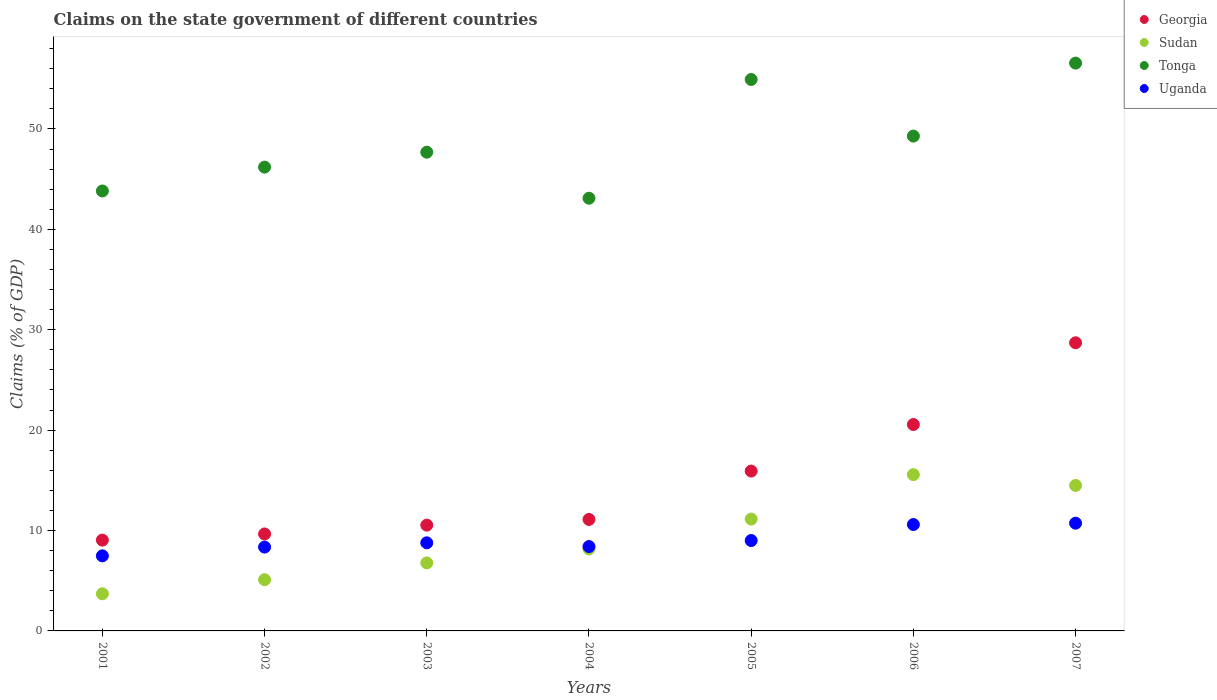Is the number of dotlines equal to the number of legend labels?
Give a very brief answer. Yes. What is the percentage of GDP claimed on the state government in Tonga in 2002?
Your answer should be very brief. 46.2. Across all years, what is the maximum percentage of GDP claimed on the state government in Uganda?
Provide a short and direct response. 10.73. Across all years, what is the minimum percentage of GDP claimed on the state government in Tonga?
Make the answer very short. 43.1. In which year was the percentage of GDP claimed on the state government in Sudan minimum?
Ensure brevity in your answer.  2001. What is the total percentage of GDP claimed on the state government in Tonga in the graph?
Keep it short and to the point. 341.59. What is the difference between the percentage of GDP claimed on the state government in Uganda in 2004 and that in 2005?
Your response must be concise. -0.6. What is the difference between the percentage of GDP claimed on the state government in Sudan in 2001 and the percentage of GDP claimed on the state government in Tonga in 2007?
Provide a short and direct response. -52.86. What is the average percentage of GDP claimed on the state government in Georgia per year?
Your answer should be compact. 15.08. In the year 2004, what is the difference between the percentage of GDP claimed on the state government in Tonga and percentage of GDP claimed on the state government in Sudan?
Make the answer very short. 34.94. In how many years, is the percentage of GDP claimed on the state government in Uganda greater than 44 %?
Provide a succinct answer. 0. What is the ratio of the percentage of GDP claimed on the state government in Tonga in 2001 to that in 2005?
Your answer should be compact. 0.8. Is the percentage of GDP claimed on the state government in Uganda in 2004 less than that in 2005?
Give a very brief answer. Yes. Is the difference between the percentage of GDP claimed on the state government in Tonga in 2001 and 2005 greater than the difference between the percentage of GDP claimed on the state government in Sudan in 2001 and 2005?
Keep it short and to the point. No. What is the difference between the highest and the second highest percentage of GDP claimed on the state government in Georgia?
Offer a very short reply. 8.14. What is the difference between the highest and the lowest percentage of GDP claimed on the state government in Tonga?
Keep it short and to the point. 13.46. In how many years, is the percentage of GDP claimed on the state government in Uganda greater than the average percentage of GDP claimed on the state government in Uganda taken over all years?
Your answer should be very brief. 2. Is it the case that in every year, the sum of the percentage of GDP claimed on the state government in Sudan and percentage of GDP claimed on the state government in Tonga  is greater than the sum of percentage of GDP claimed on the state government in Uganda and percentage of GDP claimed on the state government in Georgia?
Provide a succinct answer. Yes. Is it the case that in every year, the sum of the percentage of GDP claimed on the state government in Tonga and percentage of GDP claimed on the state government in Sudan  is greater than the percentage of GDP claimed on the state government in Uganda?
Give a very brief answer. Yes. Does the percentage of GDP claimed on the state government in Uganda monotonically increase over the years?
Your answer should be compact. No. Is the percentage of GDP claimed on the state government in Sudan strictly greater than the percentage of GDP claimed on the state government in Georgia over the years?
Provide a short and direct response. No. Is the percentage of GDP claimed on the state government in Sudan strictly less than the percentage of GDP claimed on the state government in Tonga over the years?
Your answer should be compact. Yes. How many dotlines are there?
Your answer should be very brief. 4. How many years are there in the graph?
Your answer should be very brief. 7. Does the graph contain any zero values?
Provide a short and direct response. No. How are the legend labels stacked?
Your answer should be very brief. Vertical. What is the title of the graph?
Your answer should be compact. Claims on the state government of different countries. What is the label or title of the X-axis?
Give a very brief answer. Years. What is the label or title of the Y-axis?
Make the answer very short. Claims (% of GDP). What is the Claims (% of GDP) of Georgia in 2001?
Give a very brief answer. 9.05. What is the Claims (% of GDP) of Sudan in 2001?
Your answer should be very brief. 3.7. What is the Claims (% of GDP) in Tonga in 2001?
Offer a terse response. 43.82. What is the Claims (% of GDP) in Uganda in 2001?
Your response must be concise. 7.48. What is the Claims (% of GDP) in Georgia in 2002?
Keep it short and to the point. 9.66. What is the Claims (% of GDP) of Sudan in 2002?
Make the answer very short. 5.1. What is the Claims (% of GDP) of Tonga in 2002?
Offer a very short reply. 46.2. What is the Claims (% of GDP) of Uganda in 2002?
Keep it short and to the point. 8.35. What is the Claims (% of GDP) in Georgia in 2003?
Make the answer very short. 10.54. What is the Claims (% of GDP) in Sudan in 2003?
Keep it short and to the point. 6.77. What is the Claims (% of GDP) in Tonga in 2003?
Your answer should be compact. 47.69. What is the Claims (% of GDP) of Uganda in 2003?
Your response must be concise. 8.78. What is the Claims (% of GDP) in Georgia in 2004?
Give a very brief answer. 11.1. What is the Claims (% of GDP) of Sudan in 2004?
Offer a very short reply. 8.17. What is the Claims (% of GDP) of Tonga in 2004?
Ensure brevity in your answer.  43.1. What is the Claims (% of GDP) in Uganda in 2004?
Your answer should be very brief. 8.4. What is the Claims (% of GDP) in Georgia in 2005?
Your answer should be compact. 15.92. What is the Claims (% of GDP) in Sudan in 2005?
Make the answer very short. 11.14. What is the Claims (% of GDP) of Tonga in 2005?
Offer a terse response. 54.93. What is the Claims (% of GDP) of Uganda in 2005?
Your answer should be very brief. 9. What is the Claims (% of GDP) of Georgia in 2006?
Your response must be concise. 20.56. What is the Claims (% of GDP) in Sudan in 2006?
Offer a very short reply. 15.57. What is the Claims (% of GDP) in Tonga in 2006?
Your answer should be compact. 49.29. What is the Claims (% of GDP) in Uganda in 2006?
Offer a terse response. 10.6. What is the Claims (% of GDP) in Georgia in 2007?
Provide a short and direct response. 28.7. What is the Claims (% of GDP) in Sudan in 2007?
Offer a terse response. 14.49. What is the Claims (% of GDP) of Tonga in 2007?
Your answer should be very brief. 56.56. What is the Claims (% of GDP) of Uganda in 2007?
Give a very brief answer. 10.73. Across all years, what is the maximum Claims (% of GDP) in Georgia?
Provide a succinct answer. 28.7. Across all years, what is the maximum Claims (% of GDP) in Sudan?
Provide a succinct answer. 15.57. Across all years, what is the maximum Claims (% of GDP) in Tonga?
Your response must be concise. 56.56. Across all years, what is the maximum Claims (% of GDP) of Uganda?
Your answer should be compact. 10.73. Across all years, what is the minimum Claims (% of GDP) in Georgia?
Your response must be concise. 9.05. Across all years, what is the minimum Claims (% of GDP) in Sudan?
Offer a very short reply. 3.7. Across all years, what is the minimum Claims (% of GDP) of Tonga?
Make the answer very short. 43.1. Across all years, what is the minimum Claims (% of GDP) of Uganda?
Your answer should be very brief. 7.48. What is the total Claims (% of GDP) of Georgia in the graph?
Keep it short and to the point. 105.53. What is the total Claims (% of GDP) of Sudan in the graph?
Provide a short and direct response. 64.94. What is the total Claims (% of GDP) in Tonga in the graph?
Give a very brief answer. 341.59. What is the total Claims (% of GDP) in Uganda in the graph?
Provide a short and direct response. 63.34. What is the difference between the Claims (% of GDP) of Georgia in 2001 and that in 2002?
Keep it short and to the point. -0.61. What is the difference between the Claims (% of GDP) of Sudan in 2001 and that in 2002?
Provide a short and direct response. -1.41. What is the difference between the Claims (% of GDP) in Tonga in 2001 and that in 2002?
Give a very brief answer. -2.37. What is the difference between the Claims (% of GDP) of Uganda in 2001 and that in 2002?
Offer a very short reply. -0.87. What is the difference between the Claims (% of GDP) in Georgia in 2001 and that in 2003?
Keep it short and to the point. -1.49. What is the difference between the Claims (% of GDP) in Sudan in 2001 and that in 2003?
Make the answer very short. -3.08. What is the difference between the Claims (% of GDP) of Tonga in 2001 and that in 2003?
Ensure brevity in your answer.  -3.86. What is the difference between the Claims (% of GDP) in Uganda in 2001 and that in 2003?
Give a very brief answer. -1.3. What is the difference between the Claims (% of GDP) in Georgia in 2001 and that in 2004?
Offer a very short reply. -2.06. What is the difference between the Claims (% of GDP) in Sudan in 2001 and that in 2004?
Your answer should be very brief. -4.47. What is the difference between the Claims (% of GDP) in Tonga in 2001 and that in 2004?
Keep it short and to the point. 0.72. What is the difference between the Claims (% of GDP) of Uganda in 2001 and that in 2004?
Make the answer very short. -0.92. What is the difference between the Claims (% of GDP) of Georgia in 2001 and that in 2005?
Provide a succinct answer. -6.88. What is the difference between the Claims (% of GDP) in Sudan in 2001 and that in 2005?
Provide a succinct answer. -7.44. What is the difference between the Claims (% of GDP) in Tonga in 2001 and that in 2005?
Your response must be concise. -11.1. What is the difference between the Claims (% of GDP) in Uganda in 2001 and that in 2005?
Give a very brief answer. -1.52. What is the difference between the Claims (% of GDP) of Georgia in 2001 and that in 2006?
Make the answer very short. -11.51. What is the difference between the Claims (% of GDP) of Sudan in 2001 and that in 2006?
Your response must be concise. -11.87. What is the difference between the Claims (% of GDP) in Tonga in 2001 and that in 2006?
Give a very brief answer. -5.47. What is the difference between the Claims (% of GDP) in Uganda in 2001 and that in 2006?
Your response must be concise. -3.12. What is the difference between the Claims (% of GDP) of Georgia in 2001 and that in 2007?
Your response must be concise. -19.66. What is the difference between the Claims (% of GDP) in Sudan in 2001 and that in 2007?
Your response must be concise. -10.79. What is the difference between the Claims (% of GDP) of Tonga in 2001 and that in 2007?
Keep it short and to the point. -12.74. What is the difference between the Claims (% of GDP) in Uganda in 2001 and that in 2007?
Make the answer very short. -3.25. What is the difference between the Claims (% of GDP) of Georgia in 2002 and that in 2003?
Your answer should be compact. -0.88. What is the difference between the Claims (% of GDP) in Sudan in 2002 and that in 2003?
Offer a very short reply. -1.67. What is the difference between the Claims (% of GDP) of Tonga in 2002 and that in 2003?
Give a very brief answer. -1.49. What is the difference between the Claims (% of GDP) in Uganda in 2002 and that in 2003?
Your response must be concise. -0.42. What is the difference between the Claims (% of GDP) in Georgia in 2002 and that in 2004?
Provide a short and direct response. -1.45. What is the difference between the Claims (% of GDP) of Sudan in 2002 and that in 2004?
Provide a succinct answer. -3.06. What is the difference between the Claims (% of GDP) in Tonga in 2002 and that in 2004?
Make the answer very short. 3.1. What is the difference between the Claims (% of GDP) of Uganda in 2002 and that in 2004?
Keep it short and to the point. -0.05. What is the difference between the Claims (% of GDP) in Georgia in 2002 and that in 2005?
Ensure brevity in your answer.  -6.26. What is the difference between the Claims (% of GDP) of Sudan in 2002 and that in 2005?
Your answer should be very brief. -6.04. What is the difference between the Claims (% of GDP) in Tonga in 2002 and that in 2005?
Your answer should be compact. -8.73. What is the difference between the Claims (% of GDP) of Uganda in 2002 and that in 2005?
Offer a very short reply. -0.65. What is the difference between the Claims (% of GDP) in Georgia in 2002 and that in 2006?
Ensure brevity in your answer.  -10.9. What is the difference between the Claims (% of GDP) of Sudan in 2002 and that in 2006?
Give a very brief answer. -10.46. What is the difference between the Claims (% of GDP) in Tonga in 2002 and that in 2006?
Your response must be concise. -3.09. What is the difference between the Claims (% of GDP) in Uganda in 2002 and that in 2006?
Your answer should be very brief. -2.25. What is the difference between the Claims (% of GDP) of Georgia in 2002 and that in 2007?
Offer a terse response. -19.04. What is the difference between the Claims (% of GDP) of Sudan in 2002 and that in 2007?
Offer a terse response. -9.39. What is the difference between the Claims (% of GDP) of Tonga in 2002 and that in 2007?
Your answer should be very brief. -10.36. What is the difference between the Claims (% of GDP) in Uganda in 2002 and that in 2007?
Provide a short and direct response. -2.38. What is the difference between the Claims (% of GDP) in Georgia in 2003 and that in 2004?
Provide a short and direct response. -0.57. What is the difference between the Claims (% of GDP) of Sudan in 2003 and that in 2004?
Your response must be concise. -1.39. What is the difference between the Claims (% of GDP) of Tonga in 2003 and that in 2004?
Offer a terse response. 4.58. What is the difference between the Claims (% of GDP) of Uganda in 2003 and that in 2004?
Offer a very short reply. 0.37. What is the difference between the Claims (% of GDP) of Georgia in 2003 and that in 2005?
Provide a short and direct response. -5.38. What is the difference between the Claims (% of GDP) of Sudan in 2003 and that in 2005?
Your answer should be compact. -4.36. What is the difference between the Claims (% of GDP) of Tonga in 2003 and that in 2005?
Give a very brief answer. -7.24. What is the difference between the Claims (% of GDP) of Uganda in 2003 and that in 2005?
Make the answer very short. -0.23. What is the difference between the Claims (% of GDP) in Georgia in 2003 and that in 2006?
Ensure brevity in your answer.  -10.02. What is the difference between the Claims (% of GDP) in Sudan in 2003 and that in 2006?
Provide a succinct answer. -8.79. What is the difference between the Claims (% of GDP) in Tonga in 2003 and that in 2006?
Provide a succinct answer. -1.6. What is the difference between the Claims (% of GDP) of Uganda in 2003 and that in 2006?
Provide a succinct answer. -1.82. What is the difference between the Claims (% of GDP) of Georgia in 2003 and that in 2007?
Make the answer very short. -18.16. What is the difference between the Claims (% of GDP) of Sudan in 2003 and that in 2007?
Ensure brevity in your answer.  -7.72. What is the difference between the Claims (% of GDP) of Tonga in 2003 and that in 2007?
Your answer should be compact. -8.87. What is the difference between the Claims (% of GDP) of Uganda in 2003 and that in 2007?
Ensure brevity in your answer.  -1.96. What is the difference between the Claims (% of GDP) in Georgia in 2004 and that in 2005?
Keep it short and to the point. -4.82. What is the difference between the Claims (% of GDP) of Sudan in 2004 and that in 2005?
Give a very brief answer. -2.97. What is the difference between the Claims (% of GDP) in Tonga in 2004 and that in 2005?
Ensure brevity in your answer.  -11.83. What is the difference between the Claims (% of GDP) of Uganda in 2004 and that in 2005?
Offer a very short reply. -0.6. What is the difference between the Claims (% of GDP) of Georgia in 2004 and that in 2006?
Ensure brevity in your answer.  -9.46. What is the difference between the Claims (% of GDP) of Sudan in 2004 and that in 2006?
Your answer should be compact. -7.4. What is the difference between the Claims (% of GDP) in Tonga in 2004 and that in 2006?
Provide a short and direct response. -6.19. What is the difference between the Claims (% of GDP) in Uganda in 2004 and that in 2006?
Your answer should be very brief. -2.19. What is the difference between the Claims (% of GDP) in Georgia in 2004 and that in 2007?
Your answer should be very brief. -17.6. What is the difference between the Claims (% of GDP) in Sudan in 2004 and that in 2007?
Ensure brevity in your answer.  -6.33. What is the difference between the Claims (% of GDP) of Tonga in 2004 and that in 2007?
Your answer should be compact. -13.46. What is the difference between the Claims (% of GDP) in Uganda in 2004 and that in 2007?
Keep it short and to the point. -2.33. What is the difference between the Claims (% of GDP) of Georgia in 2005 and that in 2006?
Your response must be concise. -4.64. What is the difference between the Claims (% of GDP) in Sudan in 2005 and that in 2006?
Your answer should be very brief. -4.43. What is the difference between the Claims (% of GDP) in Tonga in 2005 and that in 2006?
Make the answer very short. 5.64. What is the difference between the Claims (% of GDP) of Uganda in 2005 and that in 2006?
Provide a short and direct response. -1.6. What is the difference between the Claims (% of GDP) of Georgia in 2005 and that in 2007?
Provide a short and direct response. -12.78. What is the difference between the Claims (% of GDP) in Sudan in 2005 and that in 2007?
Provide a succinct answer. -3.35. What is the difference between the Claims (% of GDP) of Tonga in 2005 and that in 2007?
Provide a succinct answer. -1.63. What is the difference between the Claims (% of GDP) of Uganda in 2005 and that in 2007?
Provide a succinct answer. -1.73. What is the difference between the Claims (% of GDP) of Georgia in 2006 and that in 2007?
Your answer should be compact. -8.14. What is the difference between the Claims (% of GDP) in Sudan in 2006 and that in 2007?
Provide a succinct answer. 1.08. What is the difference between the Claims (% of GDP) of Tonga in 2006 and that in 2007?
Provide a short and direct response. -7.27. What is the difference between the Claims (% of GDP) of Uganda in 2006 and that in 2007?
Ensure brevity in your answer.  -0.13. What is the difference between the Claims (% of GDP) of Georgia in 2001 and the Claims (% of GDP) of Sudan in 2002?
Your response must be concise. 3.94. What is the difference between the Claims (% of GDP) in Georgia in 2001 and the Claims (% of GDP) in Tonga in 2002?
Give a very brief answer. -37.15. What is the difference between the Claims (% of GDP) in Georgia in 2001 and the Claims (% of GDP) in Uganda in 2002?
Offer a very short reply. 0.69. What is the difference between the Claims (% of GDP) in Sudan in 2001 and the Claims (% of GDP) in Tonga in 2002?
Provide a succinct answer. -42.5. What is the difference between the Claims (% of GDP) of Sudan in 2001 and the Claims (% of GDP) of Uganda in 2002?
Give a very brief answer. -4.65. What is the difference between the Claims (% of GDP) in Tonga in 2001 and the Claims (% of GDP) in Uganda in 2002?
Ensure brevity in your answer.  35.47. What is the difference between the Claims (% of GDP) in Georgia in 2001 and the Claims (% of GDP) in Sudan in 2003?
Keep it short and to the point. 2.27. What is the difference between the Claims (% of GDP) in Georgia in 2001 and the Claims (% of GDP) in Tonga in 2003?
Give a very brief answer. -38.64. What is the difference between the Claims (% of GDP) in Georgia in 2001 and the Claims (% of GDP) in Uganda in 2003?
Offer a terse response. 0.27. What is the difference between the Claims (% of GDP) in Sudan in 2001 and the Claims (% of GDP) in Tonga in 2003?
Your answer should be very brief. -43.99. What is the difference between the Claims (% of GDP) in Sudan in 2001 and the Claims (% of GDP) in Uganda in 2003?
Offer a very short reply. -5.08. What is the difference between the Claims (% of GDP) of Tonga in 2001 and the Claims (% of GDP) of Uganda in 2003?
Your answer should be compact. 35.05. What is the difference between the Claims (% of GDP) of Georgia in 2001 and the Claims (% of GDP) of Sudan in 2004?
Keep it short and to the point. 0.88. What is the difference between the Claims (% of GDP) of Georgia in 2001 and the Claims (% of GDP) of Tonga in 2004?
Make the answer very short. -34.06. What is the difference between the Claims (% of GDP) of Georgia in 2001 and the Claims (% of GDP) of Uganda in 2004?
Offer a terse response. 0.64. What is the difference between the Claims (% of GDP) in Sudan in 2001 and the Claims (% of GDP) in Tonga in 2004?
Keep it short and to the point. -39.4. What is the difference between the Claims (% of GDP) of Sudan in 2001 and the Claims (% of GDP) of Uganda in 2004?
Offer a terse response. -4.71. What is the difference between the Claims (% of GDP) in Tonga in 2001 and the Claims (% of GDP) in Uganda in 2004?
Keep it short and to the point. 35.42. What is the difference between the Claims (% of GDP) of Georgia in 2001 and the Claims (% of GDP) of Sudan in 2005?
Offer a terse response. -2.09. What is the difference between the Claims (% of GDP) in Georgia in 2001 and the Claims (% of GDP) in Tonga in 2005?
Give a very brief answer. -45.88. What is the difference between the Claims (% of GDP) of Georgia in 2001 and the Claims (% of GDP) of Uganda in 2005?
Give a very brief answer. 0.04. What is the difference between the Claims (% of GDP) of Sudan in 2001 and the Claims (% of GDP) of Tonga in 2005?
Give a very brief answer. -51.23. What is the difference between the Claims (% of GDP) in Sudan in 2001 and the Claims (% of GDP) in Uganda in 2005?
Provide a short and direct response. -5.3. What is the difference between the Claims (% of GDP) of Tonga in 2001 and the Claims (% of GDP) of Uganda in 2005?
Provide a succinct answer. 34.82. What is the difference between the Claims (% of GDP) in Georgia in 2001 and the Claims (% of GDP) in Sudan in 2006?
Offer a very short reply. -6.52. What is the difference between the Claims (% of GDP) in Georgia in 2001 and the Claims (% of GDP) in Tonga in 2006?
Your answer should be compact. -40.24. What is the difference between the Claims (% of GDP) of Georgia in 2001 and the Claims (% of GDP) of Uganda in 2006?
Your answer should be compact. -1.55. What is the difference between the Claims (% of GDP) in Sudan in 2001 and the Claims (% of GDP) in Tonga in 2006?
Your response must be concise. -45.59. What is the difference between the Claims (% of GDP) in Sudan in 2001 and the Claims (% of GDP) in Uganda in 2006?
Give a very brief answer. -6.9. What is the difference between the Claims (% of GDP) of Tonga in 2001 and the Claims (% of GDP) of Uganda in 2006?
Your answer should be very brief. 33.23. What is the difference between the Claims (% of GDP) in Georgia in 2001 and the Claims (% of GDP) in Sudan in 2007?
Ensure brevity in your answer.  -5.45. What is the difference between the Claims (% of GDP) of Georgia in 2001 and the Claims (% of GDP) of Tonga in 2007?
Make the answer very short. -47.51. What is the difference between the Claims (% of GDP) of Georgia in 2001 and the Claims (% of GDP) of Uganda in 2007?
Provide a short and direct response. -1.69. What is the difference between the Claims (% of GDP) of Sudan in 2001 and the Claims (% of GDP) of Tonga in 2007?
Provide a short and direct response. -52.86. What is the difference between the Claims (% of GDP) in Sudan in 2001 and the Claims (% of GDP) in Uganda in 2007?
Keep it short and to the point. -7.03. What is the difference between the Claims (% of GDP) in Tonga in 2001 and the Claims (% of GDP) in Uganda in 2007?
Give a very brief answer. 33.09. What is the difference between the Claims (% of GDP) of Georgia in 2002 and the Claims (% of GDP) of Sudan in 2003?
Provide a short and direct response. 2.88. What is the difference between the Claims (% of GDP) in Georgia in 2002 and the Claims (% of GDP) in Tonga in 2003?
Offer a very short reply. -38.03. What is the difference between the Claims (% of GDP) of Georgia in 2002 and the Claims (% of GDP) of Uganda in 2003?
Provide a short and direct response. 0.88. What is the difference between the Claims (% of GDP) in Sudan in 2002 and the Claims (% of GDP) in Tonga in 2003?
Offer a very short reply. -42.58. What is the difference between the Claims (% of GDP) in Sudan in 2002 and the Claims (% of GDP) in Uganda in 2003?
Keep it short and to the point. -3.67. What is the difference between the Claims (% of GDP) of Tonga in 2002 and the Claims (% of GDP) of Uganda in 2003?
Make the answer very short. 37.42. What is the difference between the Claims (% of GDP) in Georgia in 2002 and the Claims (% of GDP) in Sudan in 2004?
Your answer should be compact. 1.49. What is the difference between the Claims (% of GDP) of Georgia in 2002 and the Claims (% of GDP) of Tonga in 2004?
Offer a terse response. -33.44. What is the difference between the Claims (% of GDP) in Georgia in 2002 and the Claims (% of GDP) in Uganda in 2004?
Give a very brief answer. 1.25. What is the difference between the Claims (% of GDP) in Sudan in 2002 and the Claims (% of GDP) in Tonga in 2004?
Your answer should be very brief. -38. What is the difference between the Claims (% of GDP) of Sudan in 2002 and the Claims (% of GDP) of Uganda in 2004?
Keep it short and to the point. -3.3. What is the difference between the Claims (% of GDP) in Tonga in 2002 and the Claims (% of GDP) in Uganda in 2004?
Your answer should be compact. 37.79. What is the difference between the Claims (% of GDP) in Georgia in 2002 and the Claims (% of GDP) in Sudan in 2005?
Ensure brevity in your answer.  -1.48. What is the difference between the Claims (% of GDP) in Georgia in 2002 and the Claims (% of GDP) in Tonga in 2005?
Your answer should be very brief. -45.27. What is the difference between the Claims (% of GDP) in Georgia in 2002 and the Claims (% of GDP) in Uganda in 2005?
Ensure brevity in your answer.  0.66. What is the difference between the Claims (% of GDP) of Sudan in 2002 and the Claims (% of GDP) of Tonga in 2005?
Make the answer very short. -49.82. What is the difference between the Claims (% of GDP) of Sudan in 2002 and the Claims (% of GDP) of Uganda in 2005?
Offer a terse response. -3.9. What is the difference between the Claims (% of GDP) in Tonga in 2002 and the Claims (% of GDP) in Uganda in 2005?
Your answer should be very brief. 37.2. What is the difference between the Claims (% of GDP) of Georgia in 2002 and the Claims (% of GDP) of Sudan in 2006?
Your response must be concise. -5.91. What is the difference between the Claims (% of GDP) in Georgia in 2002 and the Claims (% of GDP) in Tonga in 2006?
Ensure brevity in your answer.  -39.63. What is the difference between the Claims (% of GDP) of Georgia in 2002 and the Claims (% of GDP) of Uganda in 2006?
Offer a very short reply. -0.94. What is the difference between the Claims (% of GDP) in Sudan in 2002 and the Claims (% of GDP) in Tonga in 2006?
Make the answer very short. -44.19. What is the difference between the Claims (% of GDP) of Sudan in 2002 and the Claims (% of GDP) of Uganda in 2006?
Give a very brief answer. -5.49. What is the difference between the Claims (% of GDP) of Tonga in 2002 and the Claims (% of GDP) of Uganda in 2006?
Provide a succinct answer. 35.6. What is the difference between the Claims (% of GDP) of Georgia in 2002 and the Claims (% of GDP) of Sudan in 2007?
Provide a succinct answer. -4.83. What is the difference between the Claims (% of GDP) in Georgia in 2002 and the Claims (% of GDP) in Tonga in 2007?
Ensure brevity in your answer.  -46.9. What is the difference between the Claims (% of GDP) of Georgia in 2002 and the Claims (% of GDP) of Uganda in 2007?
Your answer should be compact. -1.07. What is the difference between the Claims (% of GDP) of Sudan in 2002 and the Claims (% of GDP) of Tonga in 2007?
Make the answer very short. -51.46. What is the difference between the Claims (% of GDP) of Sudan in 2002 and the Claims (% of GDP) of Uganda in 2007?
Offer a terse response. -5.63. What is the difference between the Claims (% of GDP) of Tonga in 2002 and the Claims (% of GDP) of Uganda in 2007?
Keep it short and to the point. 35.47. What is the difference between the Claims (% of GDP) in Georgia in 2003 and the Claims (% of GDP) in Sudan in 2004?
Your answer should be compact. 2.37. What is the difference between the Claims (% of GDP) in Georgia in 2003 and the Claims (% of GDP) in Tonga in 2004?
Offer a very short reply. -32.56. What is the difference between the Claims (% of GDP) of Georgia in 2003 and the Claims (% of GDP) of Uganda in 2004?
Give a very brief answer. 2.13. What is the difference between the Claims (% of GDP) of Sudan in 2003 and the Claims (% of GDP) of Tonga in 2004?
Keep it short and to the point. -36.33. What is the difference between the Claims (% of GDP) in Sudan in 2003 and the Claims (% of GDP) in Uganda in 2004?
Provide a short and direct response. -1.63. What is the difference between the Claims (% of GDP) of Tonga in 2003 and the Claims (% of GDP) of Uganda in 2004?
Your response must be concise. 39.28. What is the difference between the Claims (% of GDP) in Georgia in 2003 and the Claims (% of GDP) in Sudan in 2005?
Your response must be concise. -0.6. What is the difference between the Claims (% of GDP) of Georgia in 2003 and the Claims (% of GDP) of Tonga in 2005?
Provide a succinct answer. -44.39. What is the difference between the Claims (% of GDP) in Georgia in 2003 and the Claims (% of GDP) in Uganda in 2005?
Give a very brief answer. 1.53. What is the difference between the Claims (% of GDP) in Sudan in 2003 and the Claims (% of GDP) in Tonga in 2005?
Keep it short and to the point. -48.15. What is the difference between the Claims (% of GDP) in Sudan in 2003 and the Claims (% of GDP) in Uganda in 2005?
Your answer should be very brief. -2.23. What is the difference between the Claims (% of GDP) of Tonga in 2003 and the Claims (% of GDP) of Uganda in 2005?
Your answer should be very brief. 38.68. What is the difference between the Claims (% of GDP) of Georgia in 2003 and the Claims (% of GDP) of Sudan in 2006?
Provide a short and direct response. -5.03. What is the difference between the Claims (% of GDP) of Georgia in 2003 and the Claims (% of GDP) of Tonga in 2006?
Ensure brevity in your answer.  -38.75. What is the difference between the Claims (% of GDP) in Georgia in 2003 and the Claims (% of GDP) in Uganda in 2006?
Ensure brevity in your answer.  -0.06. What is the difference between the Claims (% of GDP) of Sudan in 2003 and the Claims (% of GDP) of Tonga in 2006?
Give a very brief answer. -42.51. What is the difference between the Claims (% of GDP) in Sudan in 2003 and the Claims (% of GDP) in Uganda in 2006?
Offer a terse response. -3.82. What is the difference between the Claims (% of GDP) of Tonga in 2003 and the Claims (% of GDP) of Uganda in 2006?
Your response must be concise. 37.09. What is the difference between the Claims (% of GDP) of Georgia in 2003 and the Claims (% of GDP) of Sudan in 2007?
Ensure brevity in your answer.  -3.95. What is the difference between the Claims (% of GDP) in Georgia in 2003 and the Claims (% of GDP) in Tonga in 2007?
Offer a terse response. -46.02. What is the difference between the Claims (% of GDP) in Georgia in 2003 and the Claims (% of GDP) in Uganda in 2007?
Give a very brief answer. -0.19. What is the difference between the Claims (% of GDP) in Sudan in 2003 and the Claims (% of GDP) in Tonga in 2007?
Provide a succinct answer. -49.78. What is the difference between the Claims (% of GDP) in Sudan in 2003 and the Claims (% of GDP) in Uganda in 2007?
Provide a short and direct response. -3.96. What is the difference between the Claims (% of GDP) in Tonga in 2003 and the Claims (% of GDP) in Uganda in 2007?
Keep it short and to the point. 36.96. What is the difference between the Claims (% of GDP) of Georgia in 2004 and the Claims (% of GDP) of Sudan in 2005?
Keep it short and to the point. -0.04. What is the difference between the Claims (% of GDP) in Georgia in 2004 and the Claims (% of GDP) in Tonga in 2005?
Provide a succinct answer. -43.82. What is the difference between the Claims (% of GDP) of Georgia in 2004 and the Claims (% of GDP) of Uganda in 2005?
Provide a short and direct response. 2.1. What is the difference between the Claims (% of GDP) in Sudan in 2004 and the Claims (% of GDP) in Tonga in 2005?
Your answer should be very brief. -46.76. What is the difference between the Claims (% of GDP) of Sudan in 2004 and the Claims (% of GDP) of Uganda in 2005?
Offer a terse response. -0.84. What is the difference between the Claims (% of GDP) of Tonga in 2004 and the Claims (% of GDP) of Uganda in 2005?
Offer a terse response. 34.1. What is the difference between the Claims (% of GDP) of Georgia in 2004 and the Claims (% of GDP) of Sudan in 2006?
Your answer should be very brief. -4.46. What is the difference between the Claims (% of GDP) of Georgia in 2004 and the Claims (% of GDP) of Tonga in 2006?
Your response must be concise. -38.19. What is the difference between the Claims (% of GDP) of Georgia in 2004 and the Claims (% of GDP) of Uganda in 2006?
Make the answer very short. 0.51. What is the difference between the Claims (% of GDP) of Sudan in 2004 and the Claims (% of GDP) of Tonga in 2006?
Ensure brevity in your answer.  -41.12. What is the difference between the Claims (% of GDP) of Sudan in 2004 and the Claims (% of GDP) of Uganda in 2006?
Ensure brevity in your answer.  -2.43. What is the difference between the Claims (% of GDP) of Tonga in 2004 and the Claims (% of GDP) of Uganda in 2006?
Give a very brief answer. 32.5. What is the difference between the Claims (% of GDP) of Georgia in 2004 and the Claims (% of GDP) of Sudan in 2007?
Your answer should be compact. -3.39. What is the difference between the Claims (% of GDP) in Georgia in 2004 and the Claims (% of GDP) in Tonga in 2007?
Your response must be concise. -45.45. What is the difference between the Claims (% of GDP) in Georgia in 2004 and the Claims (% of GDP) in Uganda in 2007?
Your response must be concise. 0.37. What is the difference between the Claims (% of GDP) of Sudan in 2004 and the Claims (% of GDP) of Tonga in 2007?
Keep it short and to the point. -48.39. What is the difference between the Claims (% of GDP) in Sudan in 2004 and the Claims (% of GDP) in Uganda in 2007?
Your answer should be compact. -2.57. What is the difference between the Claims (% of GDP) of Tonga in 2004 and the Claims (% of GDP) of Uganda in 2007?
Provide a succinct answer. 32.37. What is the difference between the Claims (% of GDP) in Georgia in 2005 and the Claims (% of GDP) in Sudan in 2006?
Your answer should be compact. 0.35. What is the difference between the Claims (% of GDP) in Georgia in 2005 and the Claims (% of GDP) in Tonga in 2006?
Offer a very short reply. -33.37. What is the difference between the Claims (% of GDP) in Georgia in 2005 and the Claims (% of GDP) in Uganda in 2006?
Ensure brevity in your answer.  5.32. What is the difference between the Claims (% of GDP) of Sudan in 2005 and the Claims (% of GDP) of Tonga in 2006?
Make the answer very short. -38.15. What is the difference between the Claims (% of GDP) in Sudan in 2005 and the Claims (% of GDP) in Uganda in 2006?
Provide a short and direct response. 0.54. What is the difference between the Claims (% of GDP) of Tonga in 2005 and the Claims (% of GDP) of Uganda in 2006?
Offer a very short reply. 44.33. What is the difference between the Claims (% of GDP) of Georgia in 2005 and the Claims (% of GDP) of Sudan in 2007?
Make the answer very short. 1.43. What is the difference between the Claims (% of GDP) in Georgia in 2005 and the Claims (% of GDP) in Tonga in 2007?
Keep it short and to the point. -40.64. What is the difference between the Claims (% of GDP) in Georgia in 2005 and the Claims (% of GDP) in Uganda in 2007?
Provide a short and direct response. 5.19. What is the difference between the Claims (% of GDP) in Sudan in 2005 and the Claims (% of GDP) in Tonga in 2007?
Offer a terse response. -45.42. What is the difference between the Claims (% of GDP) in Sudan in 2005 and the Claims (% of GDP) in Uganda in 2007?
Provide a succinct answer. 0.41. What is the difference between the Claims (% of GDP) in Tonga in 2005 and the Claims (% of GDP) in Uganda in 2007?
Give a very brief answer. 44.2. What is the difference between the Claims (% of GDP) in Georgia in 2006 and the Claims (% of GDP) in Sudan in 2007?
Your response must be concise. 6.07. What is the difference between the Claims (% of GDP) of Georgia in 2006 and the Claims (% of GDP) of Tonga in 2007?
Keep it short and to the point. -36. What is the difference between the Claims (% of GDP) in Georgia in 2006 and the Claims (% of GDP) in Uganda in 2007?
Your answer should be very brief. 9.83. What is the difference between the Claims (% of GDP) of Sudan in 2006 and the Claims (% of GDP) of Tonga in 2007?
Your answer should be compact. -40.99. What is the difference between the Claims (% of GDP) of Sudan in 2006 and the Claims (% of GDP) of Uganda in 2007?
Make the answer very short. 4.84. What is the difference between the Claims (% of GDP) in Tonga in 2006 and the Claims (% of GDP) in Uganda in 2007?
Ensure brevity in your answer.  38.56. What is the average Claims (% of GDP) of Georgia per year?
Offer a very short reply. 15.08. What is the average Claims (% of GDP) in Sudan per year?
Ensure brevity in your answer.  9.28. What is the average Claims (% of GDP) in Tonga per year?
Make the answer very short. 48.8. What is the average Claims (% of GDP) in Uganda per year?
Your response must be concise. 9.05. In the year 2001, what is the difference between the Claims (% of GDP) in Georgia and Claims (% of GDP) in Sudan?
Offer a terse response. 5.35. In the year 2001, what is the difference between the Claims (% of GDP) in Georgia and Claims (% of GDP) in Tonga?
Keep it short and to the point. -34.78. In the year 2001, what is the difference between the Claims (% of GDP) in Georgia and Claims (% of GDP) in Uganda?
Provide a short and direct response. 1.57. In the year 2001, what is the difference between the Claims (% of GDP) of Sudan and Claims (% of GDP) of Tonga?
Your answer should be compact. -40.12. In the year 2001, what is the difference between the Claims (% of GDP) in Sudan and Claims (% of GDP) in Uganda?
Provide a succinct answer. -3.78. In the year 2001, what is the difference between the Claims (% of GDP) of Tonga and Claims (% of GDP) of Uganda?
Offer a terse response. 36.34. In the year 2002, what is the difference between the Claims (% of GDP) in Georgia and Claims (% of GDP) in Sudan?
Offer a very short reply. 4.55. In the year 2002, what is the difference between the Claims (% of GDP) in Georgia and Claims (% of GDP) in Tonga?
Your response must be concise. -36.54. In the year 2002, what is the difference between the Claims (% of GDP) of Georgia and Claims (% of GDP) of Uganda?
Ensure brevity in your answer.  1.31. In the year 2002, what is the difference between the Claims (% of GDP) of Sudan and Claims (% of GDP) of Tonga?
Give a very brief answer. -41.09. In the year 2002, what is the difference between the Claims (% of GDP) of Sudan and Claims (% of GDP) of Uganda?
Make the answer very short. -3.25. In the year 2002, what is the difference between the Claims (% of GDP) in Tonga and Claims (% of GDP) in Uganda?
Your response must be concise. 37.85. In the year 2003, what is the difference between the Claims (% of GDP) in Georgia and Claims (% of GDP) in Sudan?
Keep it short and to the point. 3.76. In the year 2003, what is the difference between the Claims (% of GDP) of Georgia and Claims (% of GDP) of Tonga?
Keep it short and to the point. -37.15. In the year 2003, what is the difference between the Claims (% of GDP) of Georgia and Claims (% of GDP) of Uganda?
Your answer should be very brief. 1.76. In the year 2003, what is the difference between the Claims (% of GDP) of Sudan and Claims (% of GDP) of Tonga?
Provide a short and direct response. -40.91. In the year 2003, what is the difference between the Claims (% of GDP) of Sudan and Claims (% of GDP) of Uganda?
Keep it short and to the point. -2. In the year 2003, what is the difference between the Claims (% of GDP) in Tonga and Claims (% of GDP) in Uganda?
Make the answer very short. 38.91. In the year 2004, what is the difference between the Claims (% of GDP) in Georgia and Claims (% of GDP) in Sudan?
Offer a terse response. 2.94. In the year 2004, what is the difference between the Claims (% of GDP) of Georgia and Claims (% of GDP) of Tonga?
Give a very brief answer. -32. In the year 2004, what is the difference between the Claims (% of GDP) of Georgia and Claims (% of GDP) of Uganda?
Ensure brevity in your answer.  2.7. In the year 2004, what is the difference between the Claims (% of GDP) of Sudan and Claims (% of GDP) of Tonga?
Ensure brevity in your answer.  -34.94. In the year 2004, what is the difference between the Claims (% of GDP) of Sudan and Claims (% of GDP) of Uganda?
Offer a terse response. -0.24. In the year 2004, what is the difference between the Claims (% of GDP) in Tonga and Claims (% of GDP) in Uganda?
Provide a short and direct response. 34.7. In the year 2005, what is the difference between the Claims (% of GDP) in Georgia and Claims (% of GDP) in Sudan?
Your answer should be very brief. 4.78. In the year 2005, what is the difference between the Claims (% of GDP) of Georgia and Claims (% of GDP) of Tonga?
Provide a succinct answer. -39.01. In the year 2005, what is the difference between the Claims (% of GDP) of Georgia and Claims (% of GDP) of Uganda?
Your answer should be compact. 6.92. In the year 2005, what is the difference between the Claims (% of GDP) in Sudan and Claims (% of GDP) in Tonga?
Give a very brief answer. -43.79. In the year 2005, what is the difference between the Claims (% of GDP) in Sudan and Claims (% of GDP) in Uganda?
Your response must be concise. 2.14. In the year 2005, what is the difference between the Claims (% of GDP) of Tonga and Claims (% of GDP) of Uganda?
Ensure brevity in your answer.  45.93. In the year 2006, what is the difference between the Claims (% of GDP) of Georgia and Claims (% of GDP) of Sudan?
Keep it short and to the point. 4.99. In the year 2006, what is the difference between the Claims (% of GDP) in Georgia and Claims (% of GDP) in Tonga?
Your response must be concise. -28.73. In the year 2006, what is the difference between the Claims (% of GDP) of Georgia and Claims (% of GDP) of Uganda?
Offer a very short reply. 9.96. In the year 2006, what is the difference between the Claims (% of GDP) of Sudan and Claims (% of GDP) of Tonga?
Your response must be concise. -33.72. In the year 2006, what is the difference between the Claims (% of GDP) in Sudan and Claims (% of GDP) in Uganda?
Your response must be concise. 4.97. In the year 2006, what is the difference between the Claims (% of GDP) in Tonga and Claims (% of GDP) in Uganda?
Offer a very short reply. 38.69. In the year 2007, what is the difference between the Claims (% of GDP) of Georgia and Claims (% of GDP) of Sudan?
Make the answer very short. 14.21. In the year 2007, what is the difference between the Claims (% of GDP) of Georgia and Claims (% of GDP) of Tonga?
Your answer should be compact. -27.86. In the year 2007, what is the difference between the Claims (% of GDP) of Georgia and Claims (% of GDP) of Uganda?
Provide a succinct answer. 17.97. In the year 2007, what is the difference between the Claims (% of GDP) in Sudan and Claims (% of GDP) in Tonga?
Provide a short and direct response. -42.07. In the year 2007, what is the difference between the Claims (% of GDP) of Sudan and Claims (% of GDP) of Uganda?
Ensure brevity in your answer.  3.76. In the year 2007, what is the difference between the Claims (% of GDP) of Tonga and Claims (% of GDP) of Uganda?
Your answer should be very brief. 45.83. What is the ratio of the Claims (% of GDP) in Georgia in 2001 to that in 2002?
Your answer should be very brief. 0.94. What is the ratio of the Claims (% of GDP) of Sudan in 2001 to that in 2002?
Offer a very short reply. 0.72. What is the ratio of the Claims (% of GDP) in Tonga in 2001 to that in 2002?
Offer a very short reply. 0.95. What is the ratio of the Claims (% of GDP) of Uganda in 2001 to that in 2002?
Your answer should be compact. 0.9. What is the ratio of the Claims (% of GDP) in Georgia in 2001 to that in 2003?
Your answer should be very brief. 0.86. What is the ratio of the Claims (% of GDP) of Sudan in 2001 to that in 2003?
Your answer should be compact. 0.55. What is the ratio of the Claims (% of GDP) of Tonga in 2001 to that in 2003?
Keep it short and to the point. 0.92. What is the ratio of the Claims (% of GDP) in Uganda in 2001 to that in 2003?
Offer a very short reply. 0.85. What is the ratio of the Claims (% of GDP) in Georgia in 2001 to that in 2004?
Make the answer very short. 0.81. What is the ratio of the Claims (% of GDP) of Sudan in 2001 to that in 2004?
Give a very brief answer. 0.45. What is the ratio of the Claims (% of GDP) of Tonga in 2001 to that in 2004?
Offer a terse response. 1.02. What is the ratio of the Claims (% of GDP) in Uganda in 2001 to that in 2004?
Give a very brief answer. 0.89. What is the ratio of the Claims (% of GDP) in Georgia in 2001 to that in 2005?
Your answer should be very brief. 0.57. What is the ratio of the Claims (% of GDP) in Sudan in 2001 to that in 2005?
Your answer should be compact. 0.33. What is the ratio of the Claims (% of GDP) of Tonga in 2001 to that in 2005?
Provide a succinct answer. 0.8. What is the ratio of the Claims (% of GDP) of Uganda in 2001 to that in 2005?
Keep it short and to the point. 0.83. What is the ratio of the Claims (% of GDP) of Georgia in 2001 to that in 2006?
Your answer should be very brief. 0.44. What is the ratio of the Claims (% of GDP) in Sudan in 2001 to that in 2006?
Your answer should be very brief. 0.24. What is the ratio of the Claims (% of GDP) in Tonga in 2001 to that in 2006?
Offer a terse response. 0.89. What is the ratio of the Claims (% of GDP) in Uganda in 2001 to that in 2006?
Provide a short and direct response. 0.71. What is the ratio of the Claims (% of GDP) in Georgia in 2001 to that in 2007?
Your answer should be very brief. 0.32. What is the ratio of the Claims (% of GDP) of Sudan in 2001 to that in 2007?
Keep it short and to the point. 0.26. What is the ratio of the Claims (% of GDP) of Tonga in 2001 to that in 2007?
Give a very brief answer. 0.77. What is the ratio of the Claims (% of GDP) of Uganda in 2001 to that in 2007?
Ensure brevity in your answer.  0.7. What is the ratio of the Claims (% of GDP) of Georgia in 2002 to that in 2003?
Your answer should be very brief. 0.92. What is the ratio of the Claims (% of GDP) of Sudan in 2002 to that in 2003?
Your answer should be compact. 0.75. What is the ratio of the Claims (% of GDP) in Tonga in 2002 to that in 2003?
Make the answer very short. 0.97. What is the ratio of the Claims (% of GDP) in Uganda in 2002 to that in 2003?
Provide a short and direct response. 0.95. What is the ratio of the Claims (% of GDP) in Georgia in 2002 to that in 2004?
Offer a very short reply. 0.87. What is the ratio of the Claims (% of GDP) of Sudan in 2002 to that in 2004?
Your answer should be compact. 0.63. What is the ratio of the Claims (% of GDP) in Tonga in 2002 to that in 2004?
Offer a terse response. 1.07. What is the ratio of the Claims (% of GDP) in Georgia in 2002 to that in 2005?
Your response must be concise. 0.61. What is the ratio of the Claims (% of GDP) of Sudan in 2002 to that in 2005?
Ensure brevity in your answer.  0.46. What is the ratio of the Claims (% of GDP) in Tonga in 2002 to that in 2005?
Keep it short and to the point. 0.84. What is the ratio of the Claims (% of GDP) in Uganda in 2002 to that in 2005?
Provide a succinct answer. 0.93. What is the ratio of the Claims (% of GDP) of Georgia in 2002 to that in 2006?
Provide a short and direct response. 0.47. What is the ratio of the Claims (% of GDP) in Sudan in 2002 to that in 2006?
Offer a very short reply. 0.33. What is the ratio of the Claims (% of GDP) of Tonga in 2002 to that in 2006?
Your answer should be compact. 0.94. What is the ratio of the Claims (% of GDP) in Uganda in 2002 to that in 2006?
Provide a succinct answer. 0.79. What is the ratio of the Claims (% of GDP) of Georgia in 2002 to that in 2007?
Your answer should be very brief. 0.34. What is the ratio of the Claims (% of GDP) of Sudan in 2002 to that in 2007?
Provide a succinct answer. 0.35. What is the ratio of the Claims (% of GDP) in Tonga in 2002 to that in 2007?
Provide a succinct answer. 0.82. What is the ratio of the Claims (% of GDP) in Uganda in 2002 to that in 2007?
Your answer should be very brief. 0.78. What is the ratio of the Claims (% of GDP) of Georgia in 2003 to that in 2004?
Your response must be concise. 0.95. What is the ratio of the Claims (% of GDP) in Sudan in 2003 to that in 2004?
Offer a terse response. 0.83. What is the ratio of the Claims (% of GDP) in Tonga in 2003 to that in 2004?
Provide a succinct answer. 1.11. What is the ratio of the Claims (% of GDP) in Uganda in 2003 to that in 2004?
Keep it short and to the point. 1.04. What is the ratio of the Claims (% of GDP) in Georgia in 2003 to that in 2005?
Your answer should be compact. 0.66. What is the ratio of the Claims (% of GDP) of Sudan in 2003 to that in 2005?
Provide a succinct answer. 0.61. What is the ratio of the Claims (% of GDP) in Tonga in 2003 to that in 2005?
Your answer should be compact. 0.87. What is the ratio of the Claims (% of GDP) in Uganda in 2003 to that in 2005?
Your answer should be very brief. 0.97. What is the ratio of the Claims (% of GDP) in Georgia in 2003 to that in 2006?
Provide a succinct answer. 0.51. What is the ratio of the Claims (% of GDP) of Sudan in 2003 to that in 2006?
Your answer should be compact. 0.44. What is the ratio of the Claims (% of GDP) of Tonga in 2003 to that in 2006?
Keep it short and to the point. 0.97. What is the ratio of the Claims (% of GDP) in Uganda in 2003 to that in 2006?
Keep it short and to the point. 0.83. What is the ratio of the Claims (% of GDP) in Georgia in 2003 to that in 2007?
Your response must be concise. 0.37. What is the ratio of the Claims (% of GDP) of Sudan in 2003 to that in 2007?
Offer a terse response. 0.47. What is the ratio of the Claims (% of GDP) of Tonga in 2003 to that in 2007?
Give a very brief answer. 0.84. What is the ratio of the Claims (% of GDP) in Uganda in 2003 to that in 2007?
Make the answer very short. 0.82. What is the ratio of the Claims (% of GDP) in Georgia in 2004 to that in 2005?
Your answer should be compact. 0.7. What is the ratio of the Claims (% of GDP) of Sudan in 2004 to that in 2005?
Provide a succinct answer. 0.73. What is the ratio of the Claims (% of GDP) of Tonga in 2004 to that in 2005?
Keep it short and to the point. 0.78. What is the ratio of the Claims (% of GDP) in Uganda in 2004 to that in 2005?
Ensure brevity in your answer.  0.93. What is the ratio of the Claims (% of GDP) of Georgia in 2004 to that in 2006?
Ensure brevity in your answer.  0.54. What is the ratio of the Claims (% of GDP) of Sudan in 2004 to that in 2006?
Ensure brevity in your answer.  0.52. What is the ratio of the Claims (% of GDP) of Tonga in 2004 to that in 2006?
Your response must be concise. 0.87. What is the ratio of the Claims (% of GDP) in Uganda in 2004 to that in 2006?
Your answer should be compact. 0.79. What is the ratio of the Claims (% of GDP) of Georgia in 2004 to that in 2007?
Your response must be concise. 0.39. What is the ratio of the Claims (% of GDP) of Sudan in 2004 to that in 2007?
Offer a terse response. 0.56. What is the ratio of the Claims (% of GDP) in Tonga in 2004 to that in 2007?
Offer a very short reply. 0.76. What is the ratio of the Claims (% of GDP) of Uganda in 2004 to that in 2007?
Your answer should be compact. 0.78. What is the ratio of the Claims (% of GDP) in Georgia in 2005 to that in 2006?
Provide a succinct answer. 0.77. What is the ratio of the Claims (% of GDP) in Sudan in 2005 to that in 2006?
Your answer should be compact. 0.72. What is the ratio of the Claims (% of GDP) in Tonga in 2005 to that in 2006?
Provide a short and direct response. 1.11. What is the ratio of the Claims (% of GDP) in Uganda in 2005 to that in 2006?
Provide a short and direct response. 0.85. What is the ratio of the Claims (% of GDP) in Georgia in 2005 to that in 2007?
Give a very brief answer. 0.55. What is the ratio of the Claims (% of GDP) in Sudan in 2005 to that in 2007?
Your answer should be very brief. 0.77. What is the ratio of the Claims (% of GDP) of Tonga in 2005 to that in 2007?
Offer a terse response. 0.97. What is the ratio of the Claims (% of GDP) in Uganda in 2005 to that in 2007?
Provide a succinct answer. 0.84. What is the ratio of the Claims (% of GDP) of Georgia in 2006 to that in 2007?
Your answer should be very brief. 0.72. What is the ratio of the Claims (% of GDP) of Sudan in 2006 to that in 2007?
Offer a terse response. 1.07. What is the ratio of the Claims (% of GDP) of Tonga in 2006 to that in 2007?
Ensure brevity in your answer.  0.87. What is the ratio of the Claims (% of GDP) of Uganda in 2006 to that in 2007?
Ensure brevity in your answer.  0.99. What is the difference between the highest and the second highest Claims (% of GDP) in Georgia?
Provide a short and direct response. 8.14. What is the difference between the highest and the second highest Claims (% of GDP) in Sudan?
Your response must be concise. 1.08. What is the difference between the highest and the second highest Claims (% of GDP) of Tonga?
Offer a very short reply. 1.63. What is the difference between the highest and the second highest Claims (% of GDP) in Uganda?
Provide a succinct answer. 0.13. What is the difference between the highest and the lowest Claims (% of GDP) in Georgia?
Keep it short and to the point. 19.66. What is the difference between the highest and the lowest Claims (% of GDP) of Sudan?
Give a very brief answer. 11.87. What is the difference between the highest and the lowest Claims (% of GDP) in Tonga?
Provide a short and direct response. 13.46. What is the difference between the highest and the lowest Claims (% of GDP) of Uganda?
Ensure brevity in your answer.  3.25. 